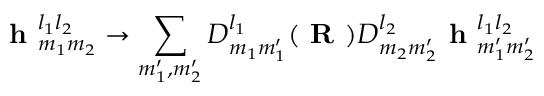Convert formula to latex. <formula><loc_0><loc_0><loc_500><loc_500>h _ { m _ { 1 } m _ { 2 } } ^ { l _ { 1 } l _ { 2 } } \to \sum _ { m _ { 1 } ^ { \prime } , m _ { 2 } ^ { \prime } } D _ { m _ { 1 } m _ { 1 } ^ { \prime } } ^ { l _ { 1 } } ( R ) D _ { m _ { 2 } m _ { 2 } ^ { \prime } } ^ { l _ { 2 } } h _ { m _ { 1 } ^ { \prime } m _ { 2 } ^ { \prime } } ^ { l _ { 1 } l _ { 2 } }</formula> 